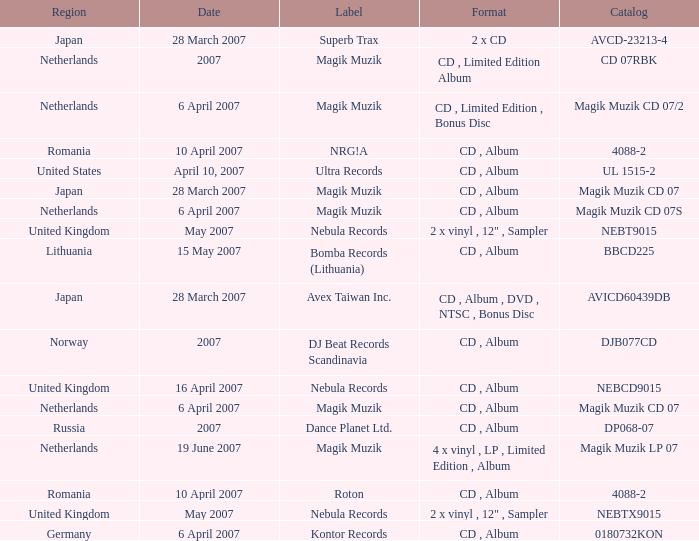For the catalog title DP068-07, what formats are available? CD , Album. 